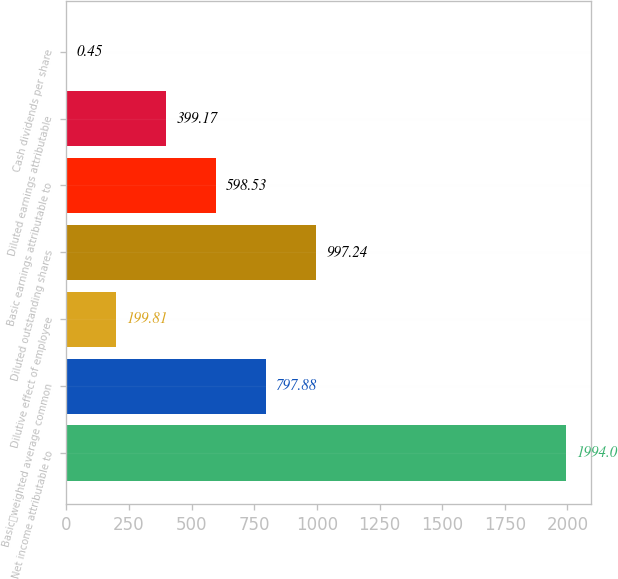Convert chart. <chart><loc_0><loc_0><loc_500><loc_500><bar_chart><fcel>Net income attributable to<fcel>Basicweighted average common<fcel>Dilutive effect of employee<fcel>Diluted outstanding shares<fcel>Basic earnings attributable to<fcel>Diluted earnings attributable<fcel>Cash dividends per share<nl><fcel>1994<fcel>797.88<fcel>199.81<fcel>997.24<fcel>598.53<fcel>399.17<fcel>0.45<nl></chart> 